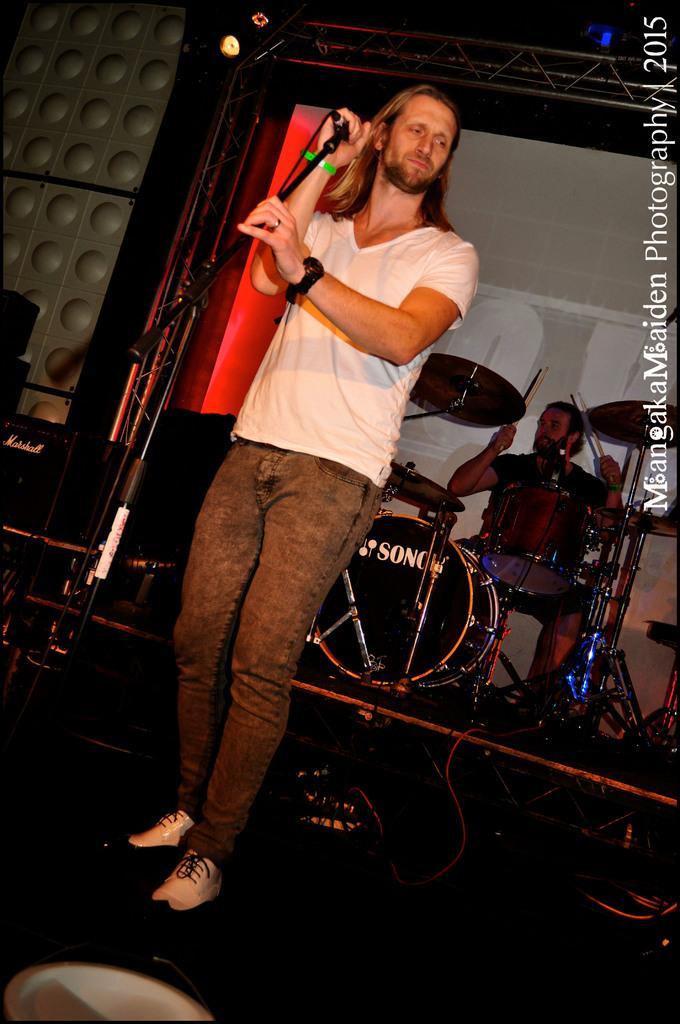Please provide a concise description of this image. In this image we can see a person wearing white T-shirt is standing here and holding the mic in his hands. In the background, we can see a person playing the electronic drums, we can see speakers and show lights. Here we can see the watermark on the right side of the image. 